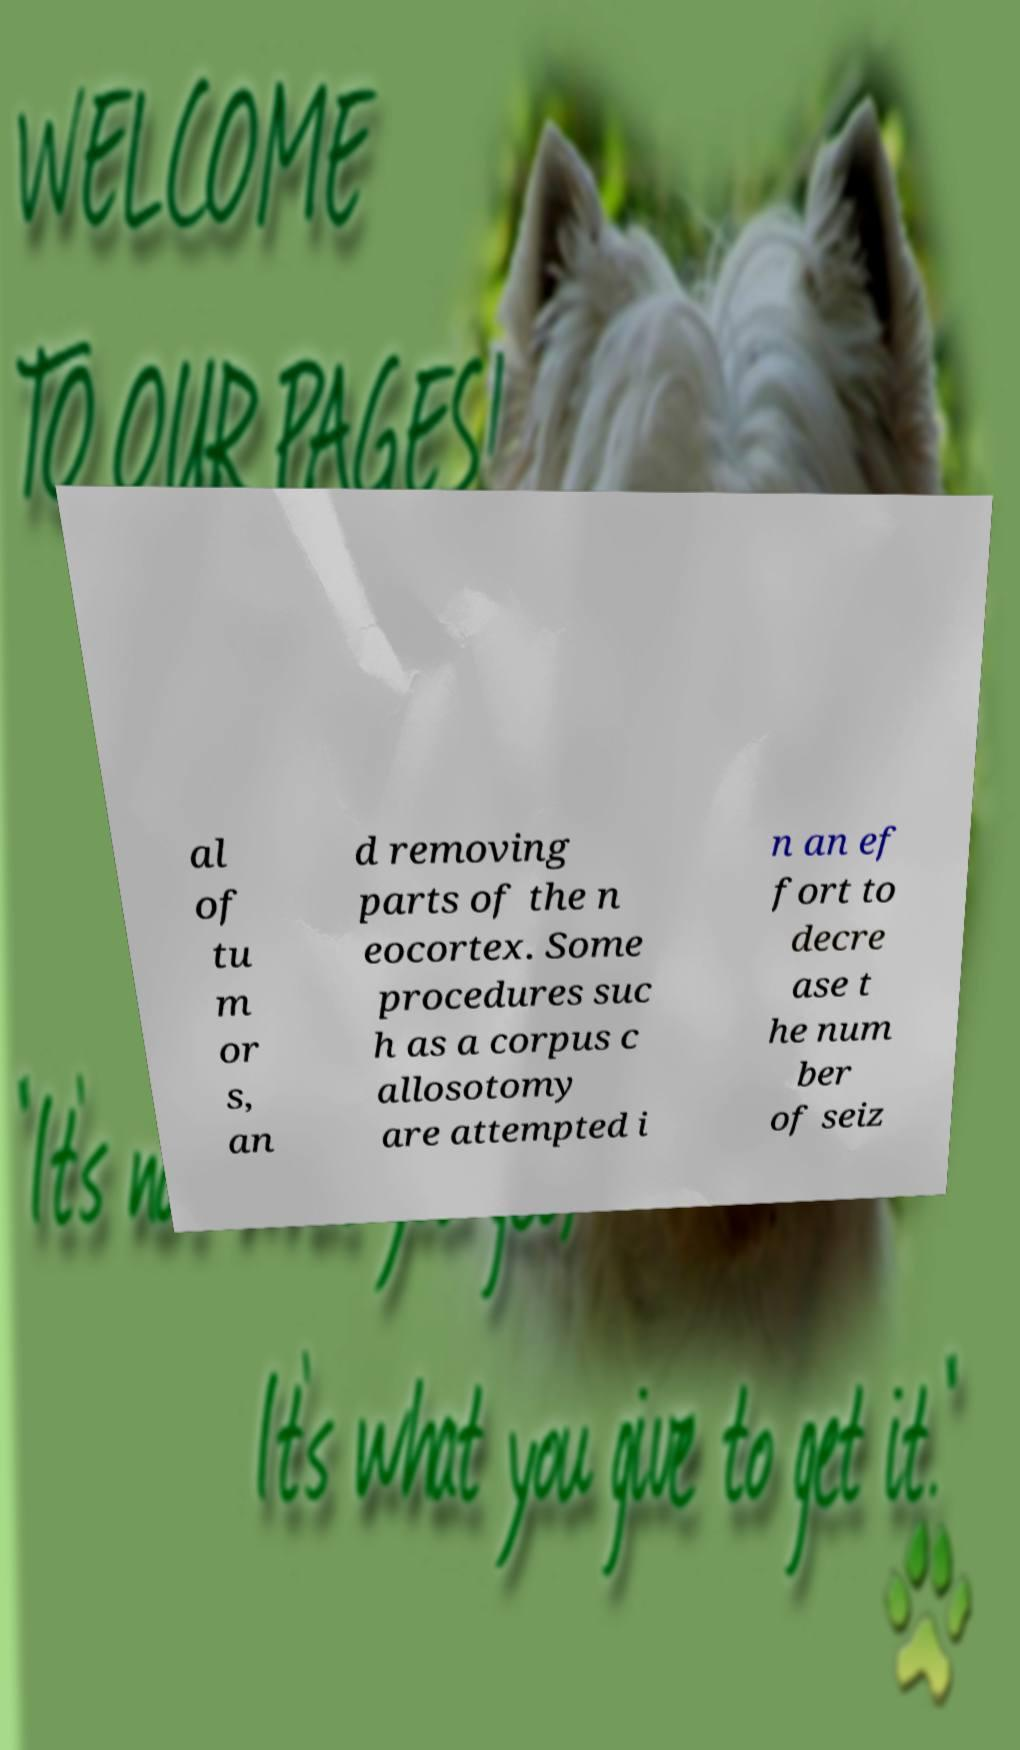What messages or text are displayed in this image? I need them in a readable, typed format. al of tu m or s, an d removing parts of the n eocortex. Some procedures suc h as a corpus c allosotomy are attempted i n an ef fort to decre ase t he num ber of seiz 